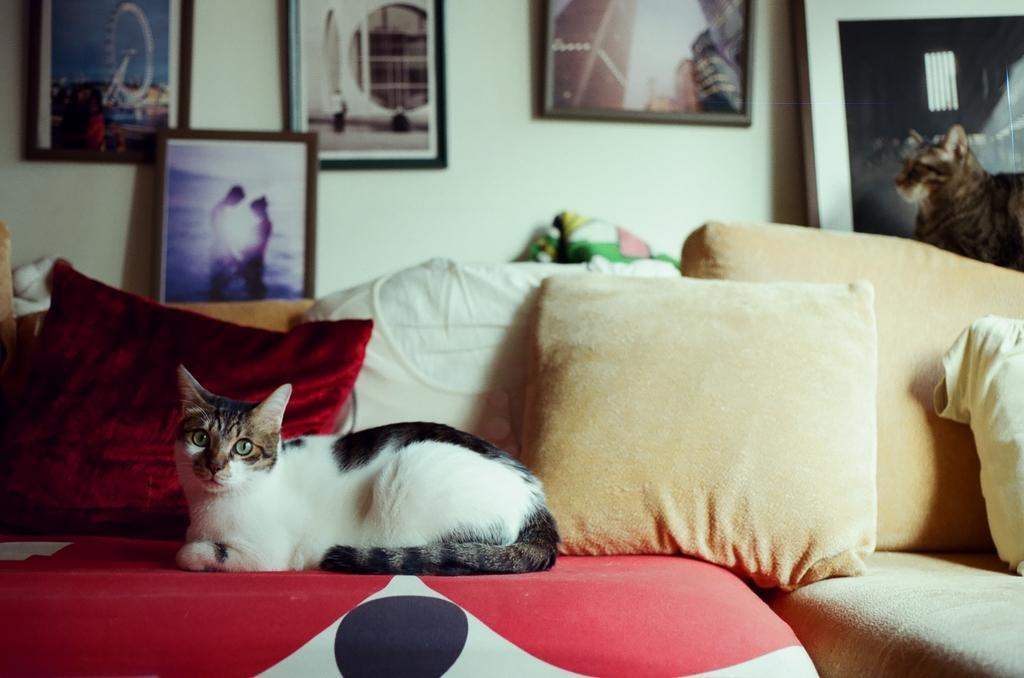Could you give a brief overview of what you see in this image? In this image I see a cat and it is on the couch and there are cushions on the couch. In the background I see the photo frames which are on the wall and I see a monitor and another cat over here. 